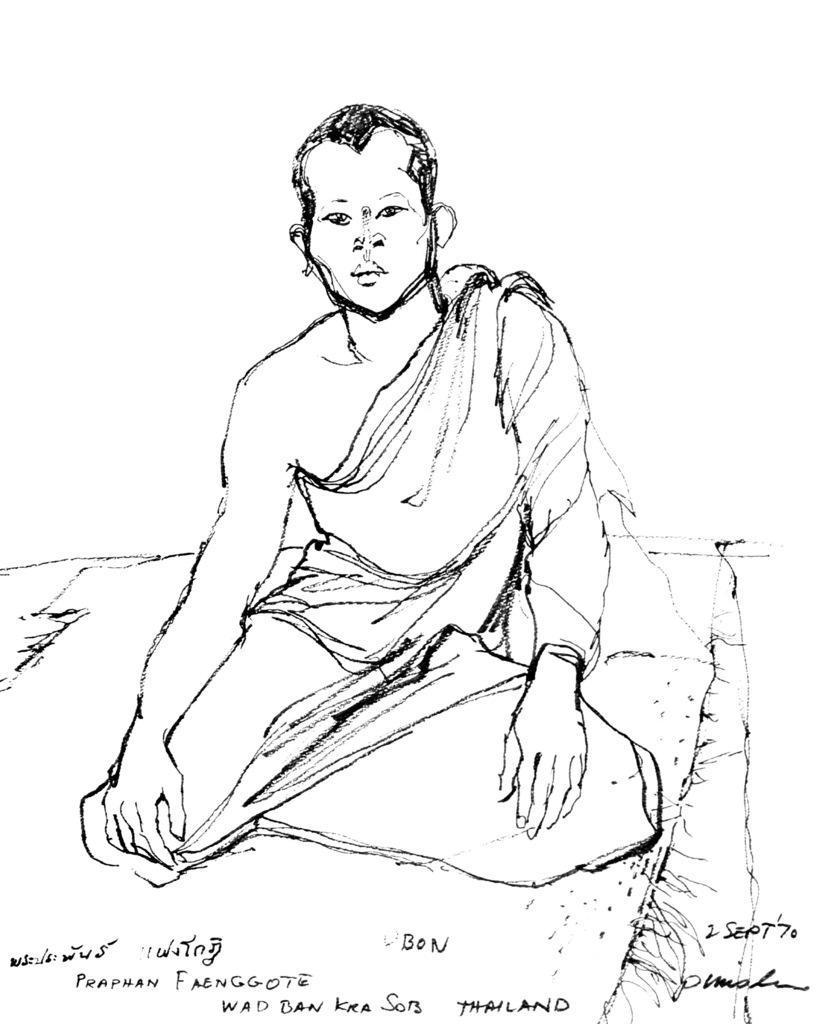In one or two sentences, can you explain what this image depicts? In this image there is a sketch of a person. There is text at the bottom. There is white colored background. 